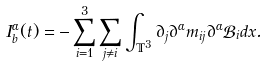<formula> <loc_0><loc_0><loc_500><loc_500>I ^ { \alpha } _ { b } ( t ) = - \sum _ { i = 1 } ^ { 3 } \sum _ { j \neq i } \int _ { \mathbb { T } ^ { 3 } } \partial _ { j } \partial ^ { \alpha } m _ { i j } \partial ^ { \alpha } \mathcal { B } _ { i } d x .</formula> 